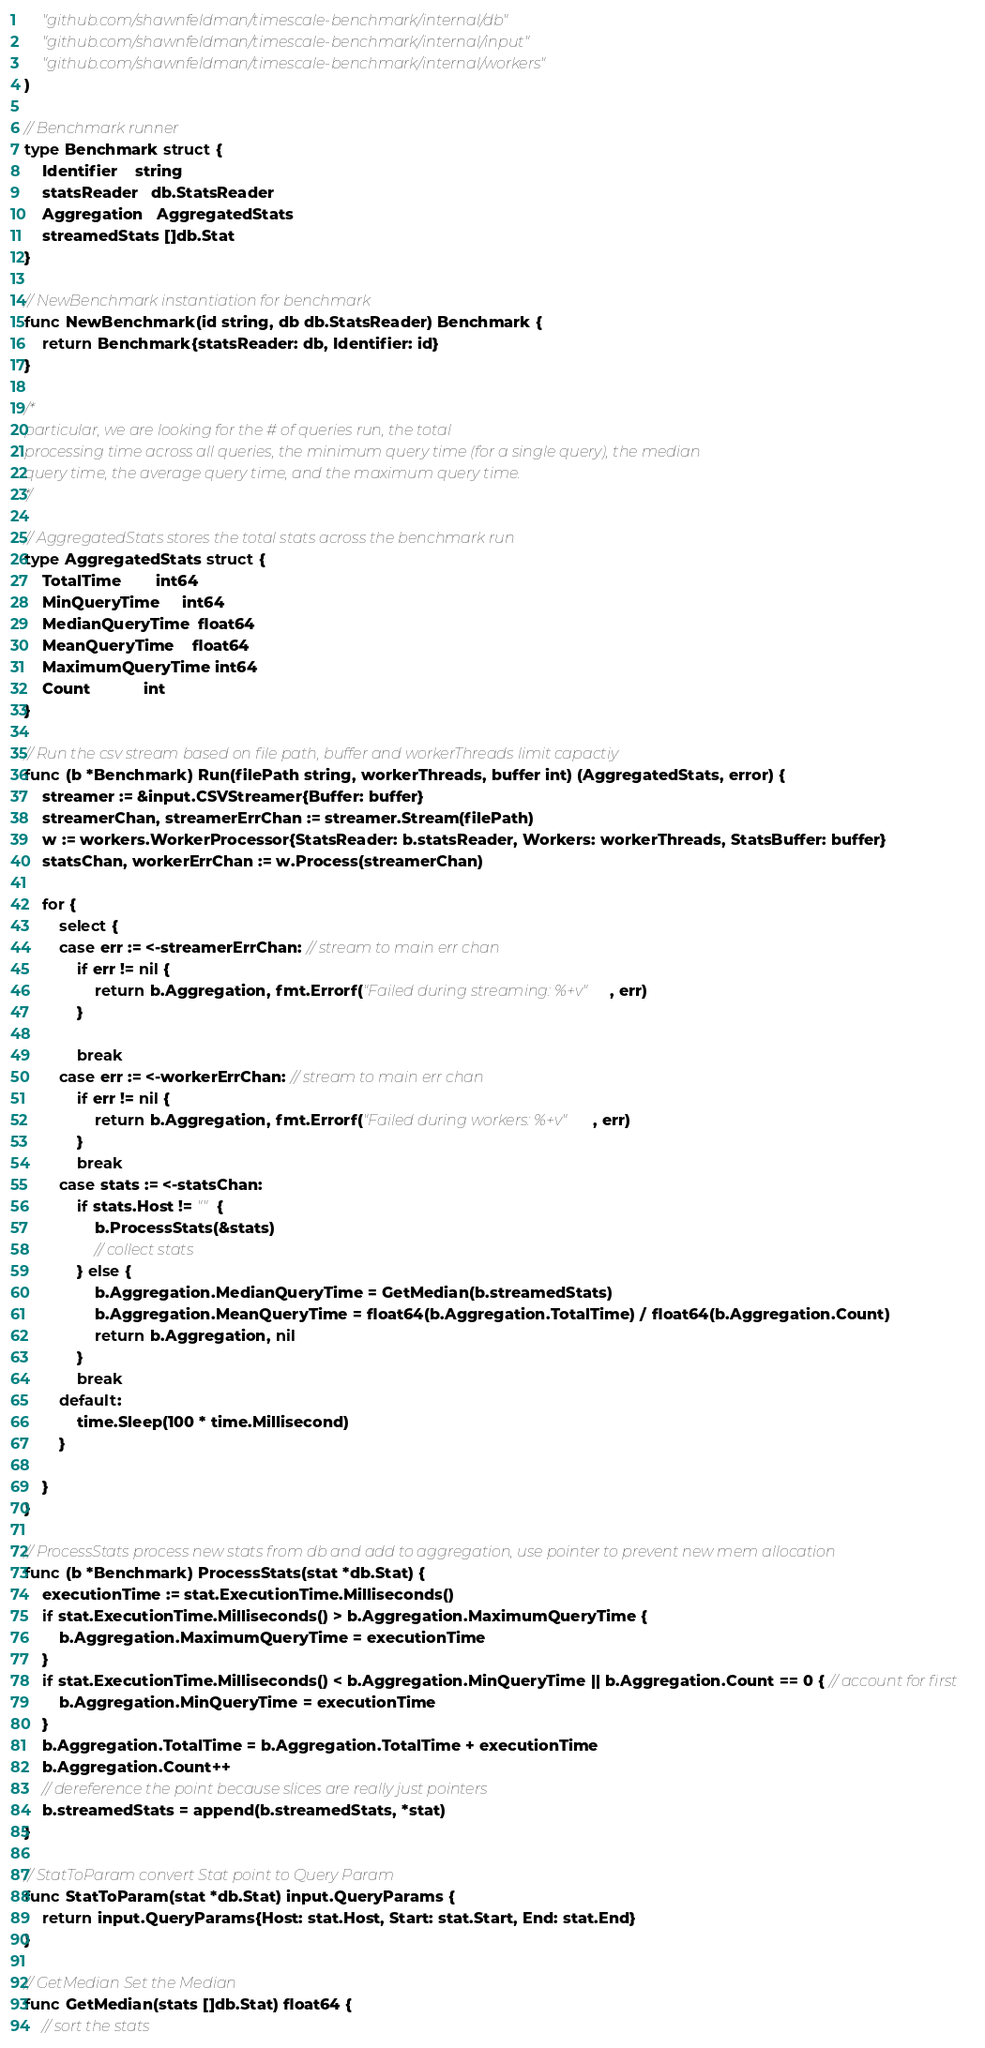Convert code to text. <code><loc_0><loc_0><loc_500><loc_500><_Go_>	"github.com/shawnfeldman/timescale-benchmark/internal/db"
	"github.com/shawnfeldman/timescale-benchmark/internal/input"
	"github.com/shawnfeldman/timescale-benchmark/internal/workers"
)

// Benchmark runner
type Benchmark struct {
	Identifier    string
	statsReader   db.StatsReader
	Aggregation   AggregatedStats
	streamedStats []db.Stat
}

// NewBenchmark instantiation for benchmark
func NewBenchmark(id string, db db.StatsReader) Benchmark {
	return Benchmark{statsReader: db, Identifier: id}
}

/*
particular, we are looking for the # of queries run, the total
processing time across all queries, the minimum query time (for a single query), the median
query time, the average query time, and the maximum query time.
*/

// AggregatedStats stores the total stats across the benchmark run
type AggregatedStats struct {
	TotalTime        int64
	MinQueryTime     int64
	MedianQueryTime  float64
	MeanQueryTime    float64
	MaximumQueryTime int64
	Count            int
}

// Run the csv stream based on file path, buffer and workerThreads limit capactiy
func (b *Benchmark) Run(filePath string, workerThreads, buffer int) (AggregatedStats, error) {
	streamer := &input.CSVStreamer{Buffer: buffer}
	streamerChan, streamerErrChan := streamer.Stream(filePath)
	w := workers.WorkerProcessor{StatsReader: b.statsReader, Workers: workerThreads, StatsBuffer: buffer}
	statsChan, workerErrChan := w.Process(streamerChan)

	for {
		select {
		case err := <-streamerErrChan: // stream to main err chan
			if err != nil {
				return b.Aggregation, fmt.Errorf("Failed during streaming: %+v", err)
			}

			break
		case err := <-workerErrChan: // stream to main err chan
			if err != nil {
				return b.Aggregation, fmt.Errorf("Failed during workers: %+v", err)
			}
			break
		case stats := <-statsChan:
			if stats.Host != "" {
				b.ProcessStats(&stats)
				// collect stats
			} else {
				b.Aggregation.MedianQueryTime = GetMedian(b.streamedStats)
				b.Aggregation.MeanQueryTime = float64(b.Aggregation.TotalTime) / float64(b.Aggregation.Count)
				return b.Aggregation, nil
			}
			break
		default:
			time.Sleep(100 * time.Millisecond)
		}

	}
}

// ProcessStats process new stats from db and add to aggregation, use pointer to prevent new mem allocation
func (b *Benchmark) ProcessStats(stat *db.Stat) {
	executionTime := stat.ExecutionTime.Milliseconds()
	if stat.ExecutionTime.Milliseconds() > b.Aggregation.MaximumQueryTime {
		b.Aggregation.MaximumQueryTime = executionTime
	}
	if stat.ExecutionTime.Milliseconds() < b.Aggregation.MinQueryTime || b.Aggregation.Count == 0 { // account for first
		b.Aggregation.MinQueryTime = executionTime
	}
	b.Aggregation.TotalTime = b.Aggregation.TotalTime + executionTime
	b.Aggregation.Count++
	// dereference the point because slices are really just pointers
	b.streamedStats = append(b.streamedStats, *stat)
}

// StatToParam convert Stat point to Query Param
func StatToParam(stat *db.Stat) input.QueryParams {
	return input.QueryParams{Host: stat.Host, Start: stat.Start, End: stat.End}
}

// GetMedian Set the Median
func GetMedian(stats []db.Stat) float64 {
	// sort the stats</code> 